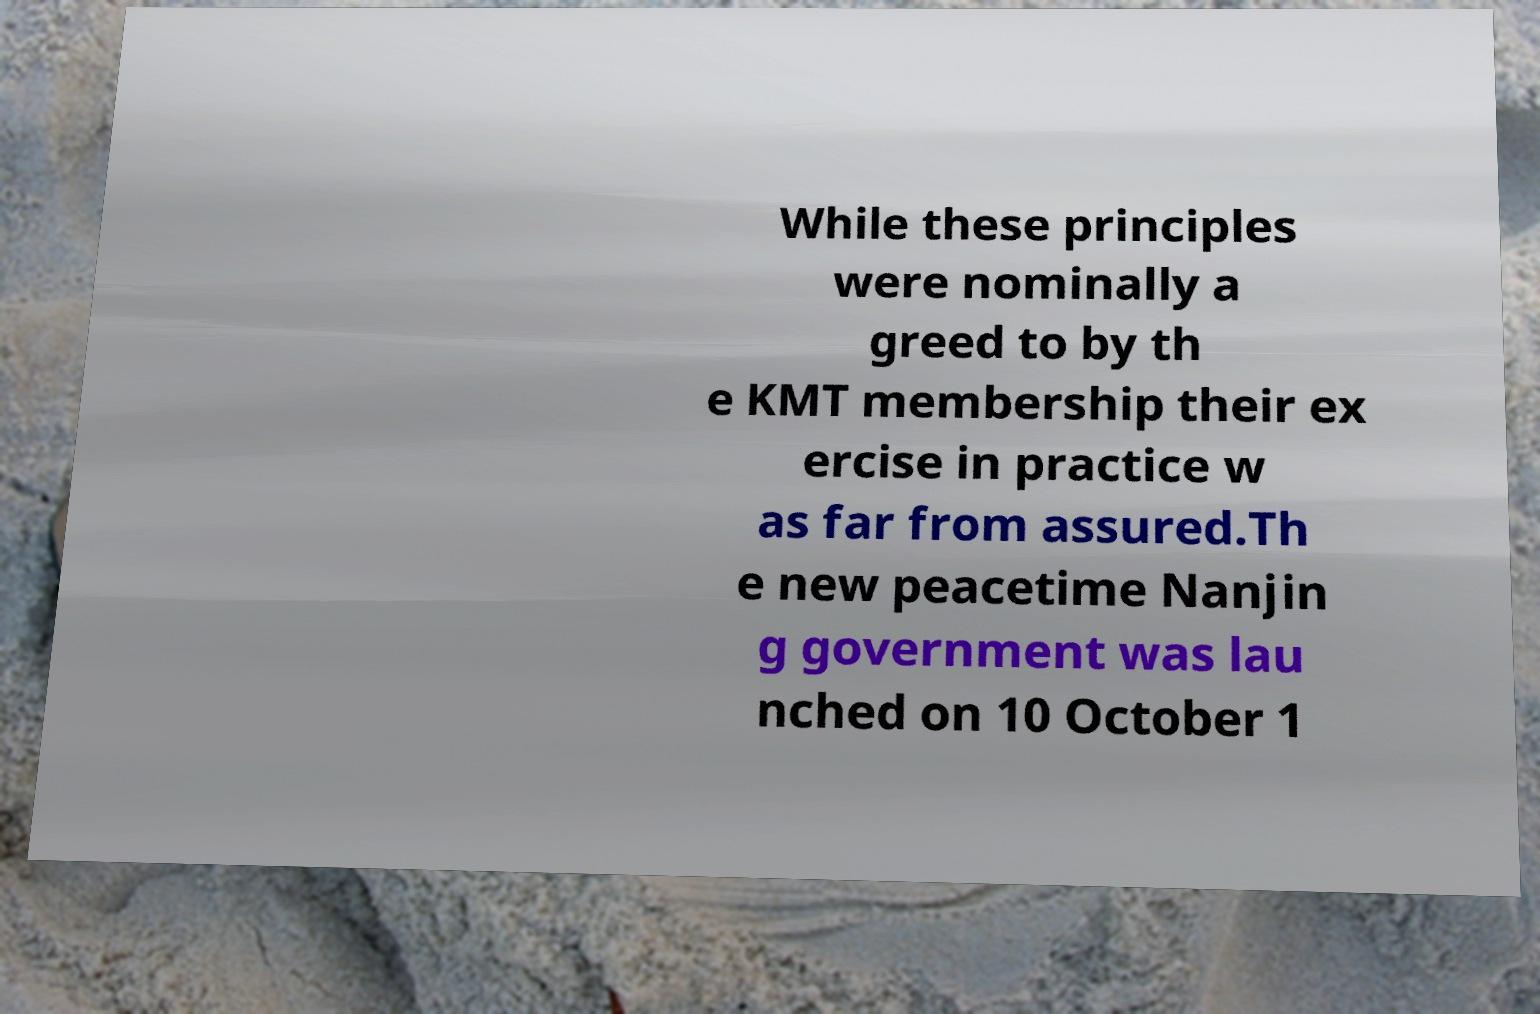For documentation purposes, I need the text within this image transcribed. Could you provide that? While these principles were nominally a greed to by th e KMT membership their ex ercise in practice w as far from assured.Th e new peacetime Nanjin g government was lau nched on 10 October 1 